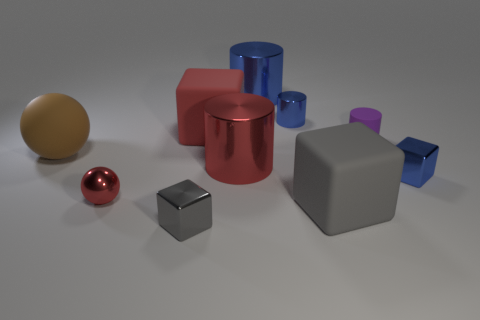The ball that is in front of the small metallic cube on the right side of the gray shiny cube is what color?
Offer a very short reply. Red. The purple rubber thing has what shape?
Your answer should be compact. Cylinder. There is a tiny metallic thing that is both on the right side of the small gray metallic block and in front of the purple matte cylinder; what is its shape?
Keep it short and to the point. Cube. The sphere that is the same material as the purple object is what color?
Make the answer very short. Brown. There is a gray thing left of the matte block left of the small blue thing behind the tiny purple matte thing; what is its shape?
Give a very brief answer. Cube. What size is the red metallic sphere?
Provide a succinct answer. Small. The purple object that is made of the same material as the big brown thing is what shape?
Ensure brevity in your answer.  Cylinder. Is the number of purple cylinders that are behind the small purple cylinder less than the number of cyan matte cubes?
Provide a succinct answer. No. The cylinder in front of the big brown matte sphere is what color?
Your answer should be very brief. Red. There is a block that is the same color as the small metallic cylinder; what is its material?
Offer a terse response. Metal. 